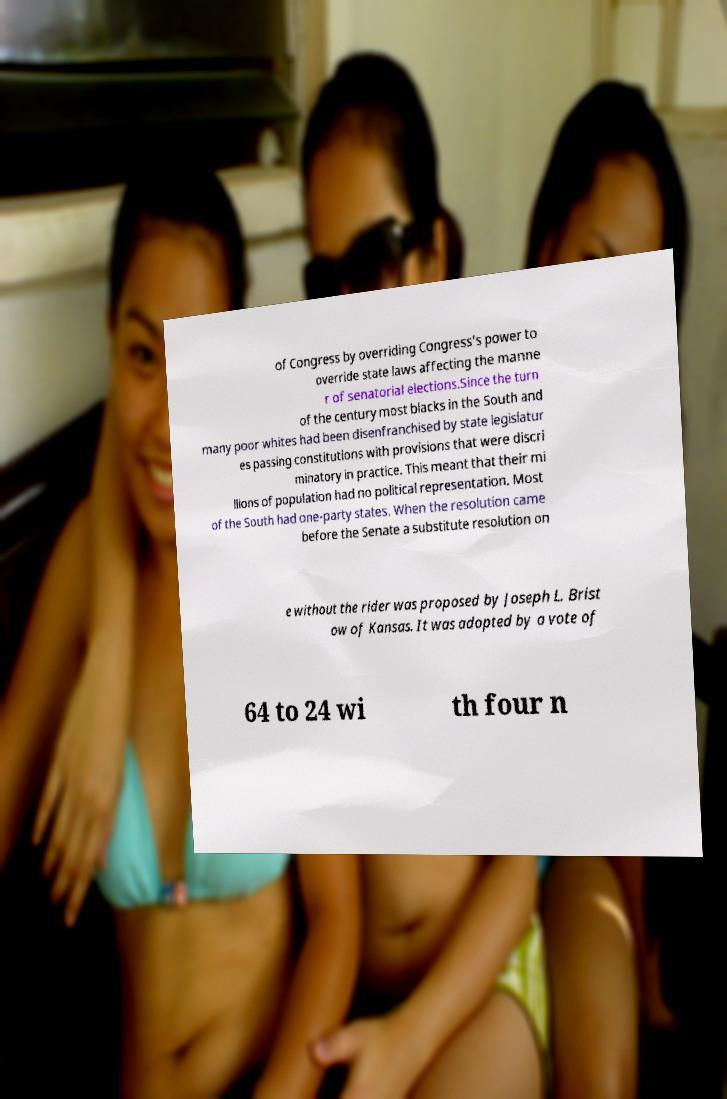There's text embedded in this image that I need extracted. Can you transcribe it verbatim? of Congress by overriding Congress's power to override state laws affecting the manne r of senatorial elections.Since the turn of the century most blacks in the South and many poor whites had been disenfranchised by state legislatur es passing constitutions with provisions that were discri minatory in practice. This meant that their mi llions of population had no political representation. Most of the South had one-party states. When the resolution came before the Senate a substitute resolution on e without the rider was proposed by Joseph L. Brist ow of Kansas. It was adopted by a vote of 64 to 24 wi th four n 